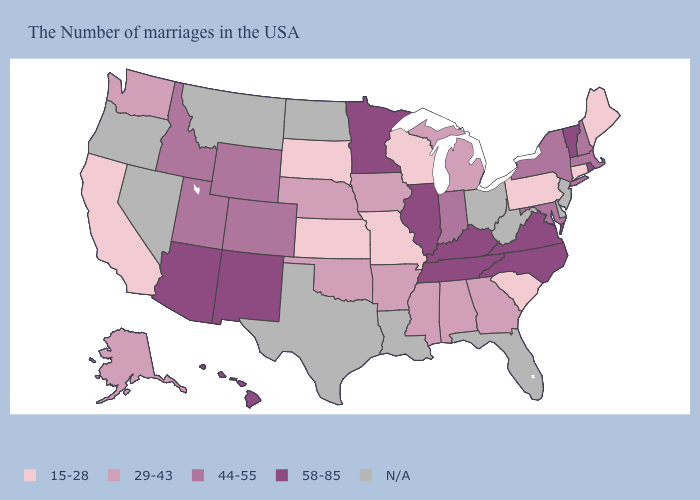Name the states that have a value in the range 29-43?
Keep it brief. Georgia, Michigan, Alabama, Mississippi, Arkansas, Iowa, Nebraska, Oklahoma, Washington, Alaska. Name the states that have a value in the range 15-28?
Short answer required. Maine, Connecticut, Pennsylvania, South Carolina, Wisconsin, Missouri, Kansas, South Dakota, California. Name the states that have a value in the range 29-43?
Quick response, please. Georgia, Michigan, Alabama, Mississippi, Arkansas, Iowa, Nebraska, Oklahoma, Washington, Alaska. Is the legend a continuous bar?
Concise answer only. No. What is the lowest value in states that border Nevada?
Quick response, please. 15-28. What is the value of South Carolina?
Give a very brief answer. 15-28. What is the value of Mississippi?
Quick response, please. 29-43. Which states have the lowest value in the South?
Keep it brief. South Carolina. What is the value of Illinois?
Quick response, please. 58-85. Name the states that have a value in the range 29-43?
Write a very short answer. Georgia, Michigan, Alabama, Mississippi, Arkansas, Iowa, Nebraska, Oklahoma, Washington, Alaska. What is the value of West Virginia?
Concise answer only. N/A. Name the states that have a value in the range 44-55?
Write a very short answer. Massachusetts, New Hampshire, New York, Maryland, Indiana, Wyoming, Colorado, Utah, Idaho. Does the map have missing data?
Write a very short answer. Yes. 